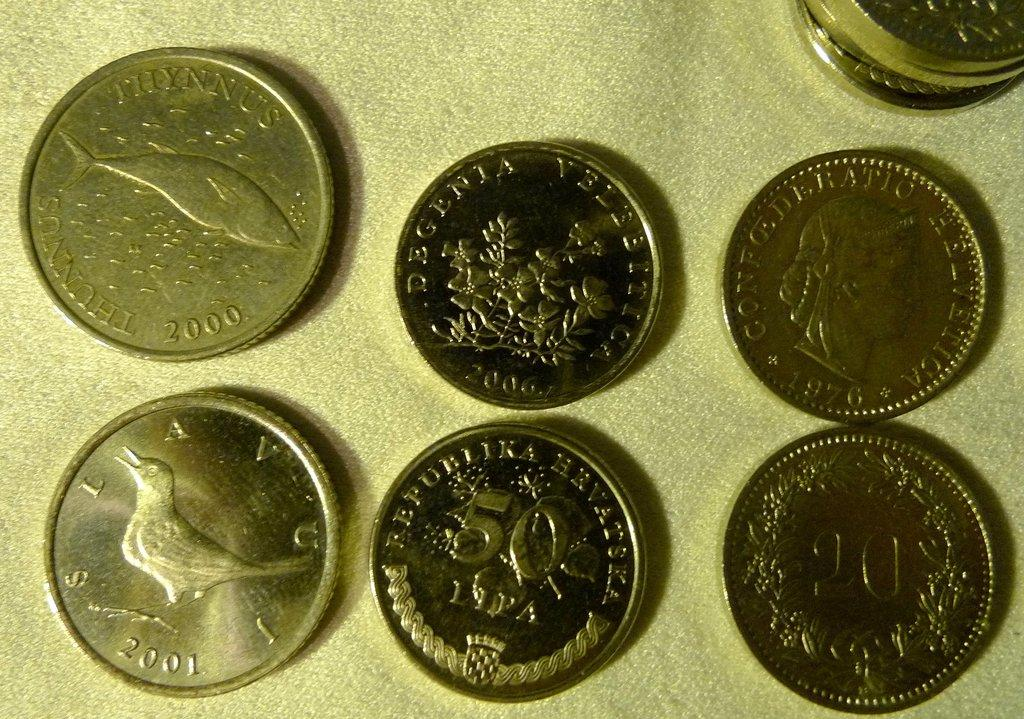Provide a one-sentence caption for the provided image. An assortment of vintage coins, one of which was printed in 2000. 